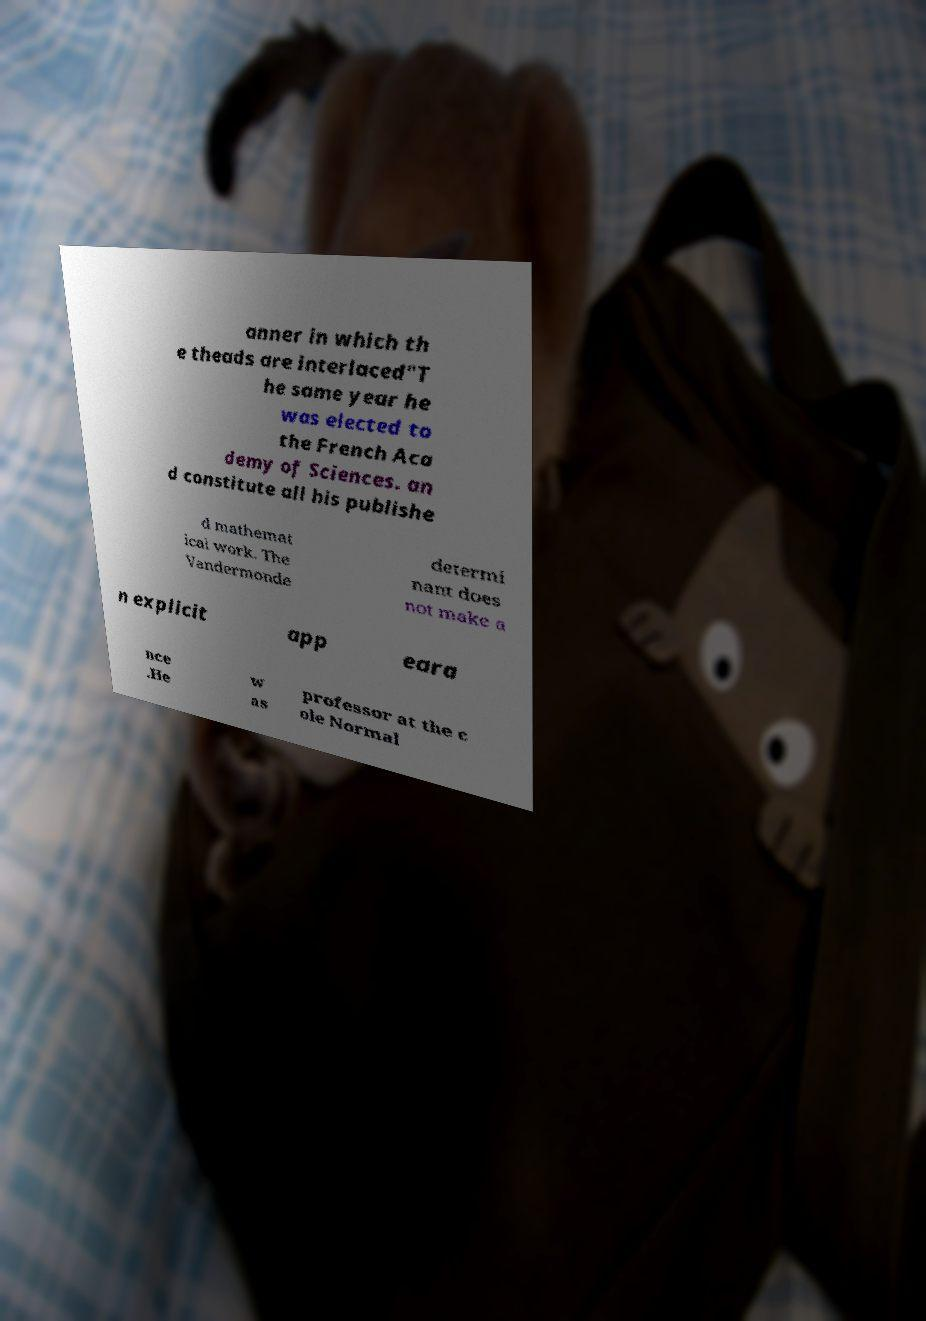There's text embedded in this image that I need extracted. Can you transcribe it verbatim? anner in which th e theads are interlaced"T he same year he was elected to the French Aca demy of Sciences. an d constitute all his publishe d mathemat ical work. The Vandermonde determi nant does not make a n explicit app eara nce .He w as professor at the c ole Normal 